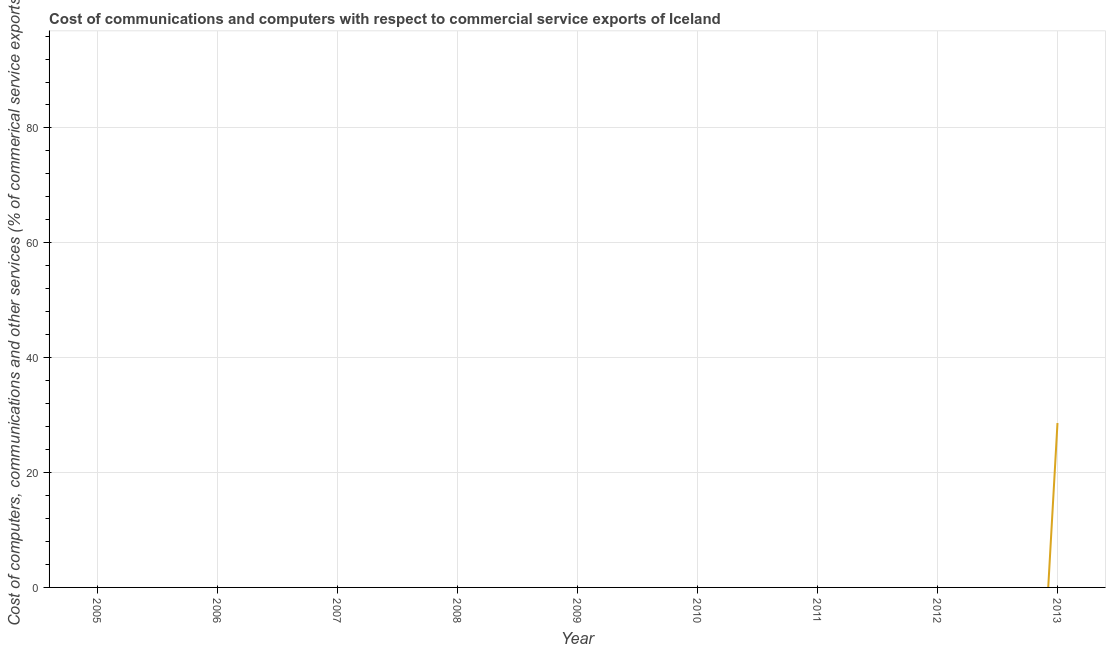What is the  computer and other services in 2008?
Make the answer very short. 0. Across all years, what is the maximum  computer and other services?
Ensure brevity in your answer.  28.63. Across all years, what is the minimum cost of communications?
Offer a terse response. 0. What is the sum of the  computer and other services?
Provide a succinct answer. 28.63. What is the average  computer and other services per year?
Make the answer very short. 3.18. What is the median cost of communications?
Offer a very short reply. 0. What is the difference between the highest and the lowest cost of communications?
Give a very brief answer. 28.63. Does the cost of communications monotonically increase over the years?
Keep it short and to the point. No. How many lines are there?
Provide a succinct answer. 1. What is the title of the graph?
Provide a succinct answer. Cost of communications and computers with respect to commercial service exports of Iceland. What is the label or title of the X-axis?
Ensure brevity in your answer.  Year. What is the label or title of the Y-axis?
Give a very brief answer. Cost of computers, communications and other services (% of commerical service exports). What is the Cost of computers, communications and other services (% of commerical service exports) of 2005?
Ensure brevity in your answer.  0. What is the Cost of computers, communications and other services (% of commerical service exports) of 2007?
Offer a very short reply. 0. What is the Cost of computers, communications and other services (% of commerical service exports) of 2009?
Your answer should be very brief. 0. What is the Cost of computers, communications and other services (% of commerical service exports) of 2010?
Your answer should be very brief. 0. What is the Cost of computers, communications and other services (% of commerical service exports) of 2011?
Provide a short and direct response. 0. What is the Cost of computers, communications and other services (% of commerical service exports) in 2013?
Your answer should be very brief. 28.63. 